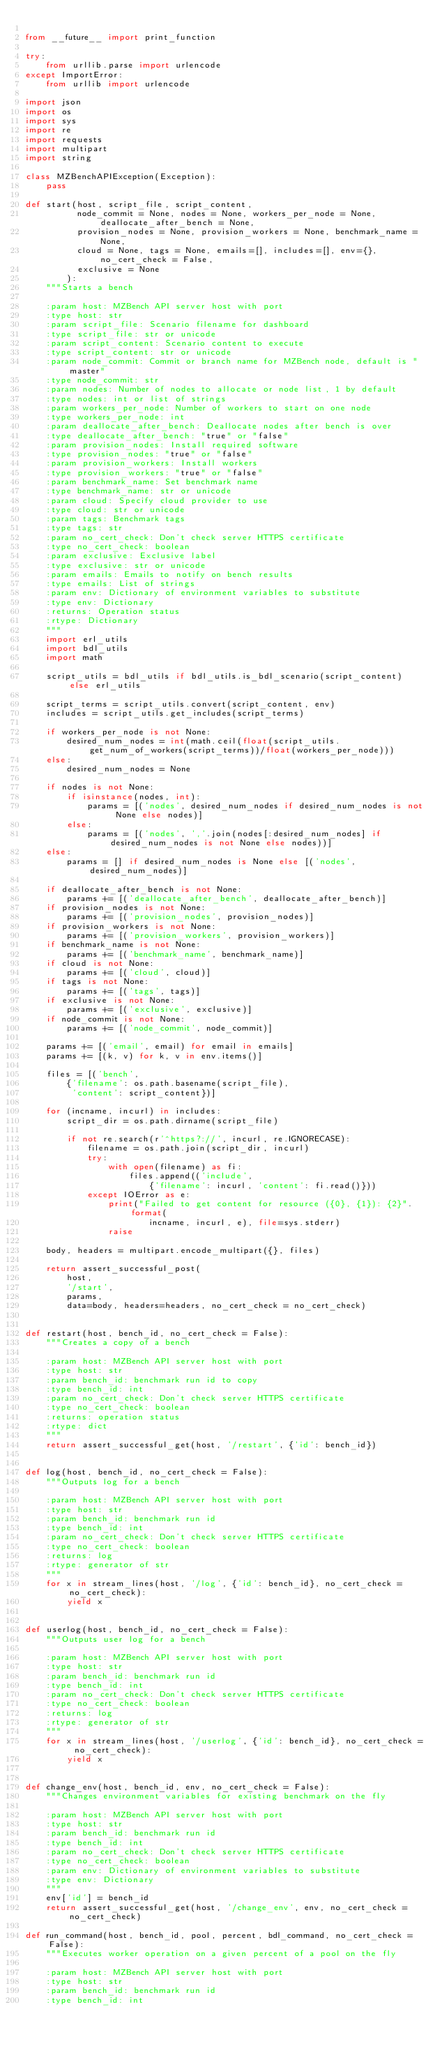Convert code to text. <code><loc_0><loc_0><loc_500><loc_500><_Python_>
from __future__ import print_function

try:
    from urllib.parse import urlencode
except ImportError:
    from urllib import urlencode

import json
import os
import sys
import re
import requests
import multipart
import string

class MZBenchAPIException(Exception):
    pass

def start(host, script_file, script_content,
          node_commit = None, nodes = None, workers_per_node = None, deallocate_after_bench = None,
          provision_nodes = None, provision_workers = None, benchmark_name = None,
          cloud = None, tags = None, emails=[], includes=[], env={}, no_cert_check = False,
          exclusive = None
        ):
    """Starts a bench

    :param host: MZBench API server host with port
    :type host: str
    :param script_file: Scenario filename for dashboard
    :type script_file: str or unicode
    :param script_content: Scenario content to execute
    :type script_content: str or unicode
    :param node_commit: Commit or branch name for MZBench node, default is "master"
    :type node_commit: str
    :param nodes: Number of nodes to allocate or node list, 1 by default
    :type nodes: int or list of strings
    :param workers_per_node: Number of workers to start on one node
    :type workers_per_node: int
    :param deallocate_after_bench: Deallocate nodes after bench is over
    :type deallocate_after_bench: "true" or "false"
    :param provision_nodes: Install required software
    :type provision_nodes: "true" or "false"
    :param provision_workers: Install workers
    :type provision_workers: "true" or "false"
    :param benchmark_name: Set benchmark name
    :type benchmark_name: str or unicode
    :param cloud: Specify cloud provider to use
    :type cloud: str or unicode
    :param tags: Benchmark tags
    :type tags: str
    :param no_cert_check: Don't check server HTTPS certificate
    :type no_cert_check: boolean
    :param exclusive: Exclusive label
    :type exclusive: str or unicode
    :param emails: Emails to notify on bench results
    :type emails: List of strings
    :param env: Dictionary of environment variables to substitute
    :type env: Dictionary
    :returns: Operation status
    :rtype: Dictionary
    """
    import erl_utils
    import bdl_utils
    import math

    script_utils = bdl_utils if bdl_utils.is_bdl_scenario(script_content) else erl_utils

    script_terms = script_utils.convert(script_content, env)
    includes = script_utils.get_includes(script_terms)

    if workers_per_node is not None:
        desired_num_nodes = int(math.ceil(float(script_utils.get_num_of_workers(script_terms))/float(workers_per_node)))
    else:
        desired_num_nodes = None

    if nodes is not None:
        if isinstance(nodes, int):
            params = [('nodes', desired_num_nodes if desired_num_nodes is not None else nodes)]
        else:
            params = [('nodes', ','.join(nodes[:desired_num_nodes] if desired_num_nodes is not None else nodes))]
    else:
        params = [] if desired_num_nodes is None else [('nodes', desired_num_nodes)]

    if deallocate_after_bench is not None:
        params += [('deallocate_after_bench', deallocate_after_bench)]
    if provision_nodes is not None:
        params += [('provision_nodes', provision_nodes)]
    if provision_workers is not None:
        params += [('provision_workers', provision_workers)]
    if benchmark_name is not None:
        params += [('benchmark_name', benchmark_name)]
    if cloud is not None:
        params += [('cloud', cloud)]
    if tags is not None:
        params += [('tags', tags)]
    if exclusive is not None:
        params += [('exclusive', exclusive)]
    if node_commit is not None:
        params += [('node_commit', node_commit)]

    params += [('email', email) for email in emails]
    params += [(k, v) for k, v in env.items()]

    files = [('bench',
        {'filename': os.path.basename(script_file),
         'content': script_content})]

    for (incname, incurl) in includes:
        script_dir = os.path.dirname(script_file)

        if not re.search(r'^https?://', incurl, re.IGNORECASE):
            filename = os.path.join(script_dir, incurl)
            try:
                with open(filename) as fi:
                    files.append(('include',
                        {'filename': incurl, 'content': fi.read()}))
            except IOError as e:
                print("Failed to get content for resource ({0}, {1}): {2}".format(
                        incname, incurl, e), file=sys.stderr)
                raise

    body, headers = multipart.encode_multipart({}, files)

    return assert_successful_post(
        host,
        '/start',
        params,
        data=body, headers=headers, no_cert_check = no_cert_check)


def restart(host, bench_id, no_cert_check = False):
    """Creates a copy of a bench

    :param host: MZBench API server host with port
    :type host: str
    :param bench_id: benchmark run id to copy
    :type bench_id: int
    :param no_cert_check: Don't check server HTTPS certificate
    :type no_cert_check: boolean
    :returns: operation status
    :rtype: dict
    """
    return assert_successful_get(host, '/restart', {'id': bench_id})


def log(host, bench_id, no_cert_check = False):
    """Outputs log for a bench

    :param host: MZBench API server host with port
    :type host: str
    :param bench_id: benchmark run id
    :type bench_id: int
    :param no_cert_check: Don't check server HTTPS certificate
    :type no_cert_check: boolean
    :returns: log
    :rtype: generator of str
    """
    for x in stream_lines(host, '/log', {'id': bench_id}, no_cert_check = no_cert_check):
        yield x


def userlog(host, bench_id, no_cert_check = False):
    """Outputs user log for a bench

    :param host: MZBench API server host with port
    :type host: str
    :param bench_id: benchmark run id
    :type bench_id: int
    :param no_cert_check: Don't check server HTTPS certificate
    :type no_cert_check: boolean
    :returns: log
    :rtype: generator of str
    """
    for x in stream_lines(host, '/userlog', {'id': bench_id}, no_cert_check = no_cert_check):
        yield x


def change_env(host, bench_id, env, no_cert_check = False):
    """Changes environment variables for existing benchmark on the fly

    :param host: MZBench API server host with port
    :type host: str
    :param bench_id: benchmark run id
    :type bench_id: int
    :param no_cert_check: Don't check server HTTPS certificate
    :type no_cert_check: boolean
    :param env: Dictionary of environment variables to substitute
    :type env: Dictionary
    """
    env['id'] = bench_id
    return assert_successful_get(host, '/change_env', env, no_cert_check = no_cert_check)

def run_command(host, bench_id, pool, percent, bdl_command, no_cert_check = False):
    """Executes worker operation on a given percent of a pool on the fly

    :param host: MZBench API server host with port
    :type host: str
    :param bench_id: benchmark run id
    :type bench_id: int</code> 